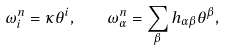Convert formula to latex. <formula><loc_0><loc_0><loc_500><loc_500>\omega ^ { n } _ { i } = \kappa \theta ^ { i } , \quad \omega ^ { n } _ { \alpha } = \sum _ { \beta } h _ { \alpha \beta } \theta ^ { \beta } ,</formula> 